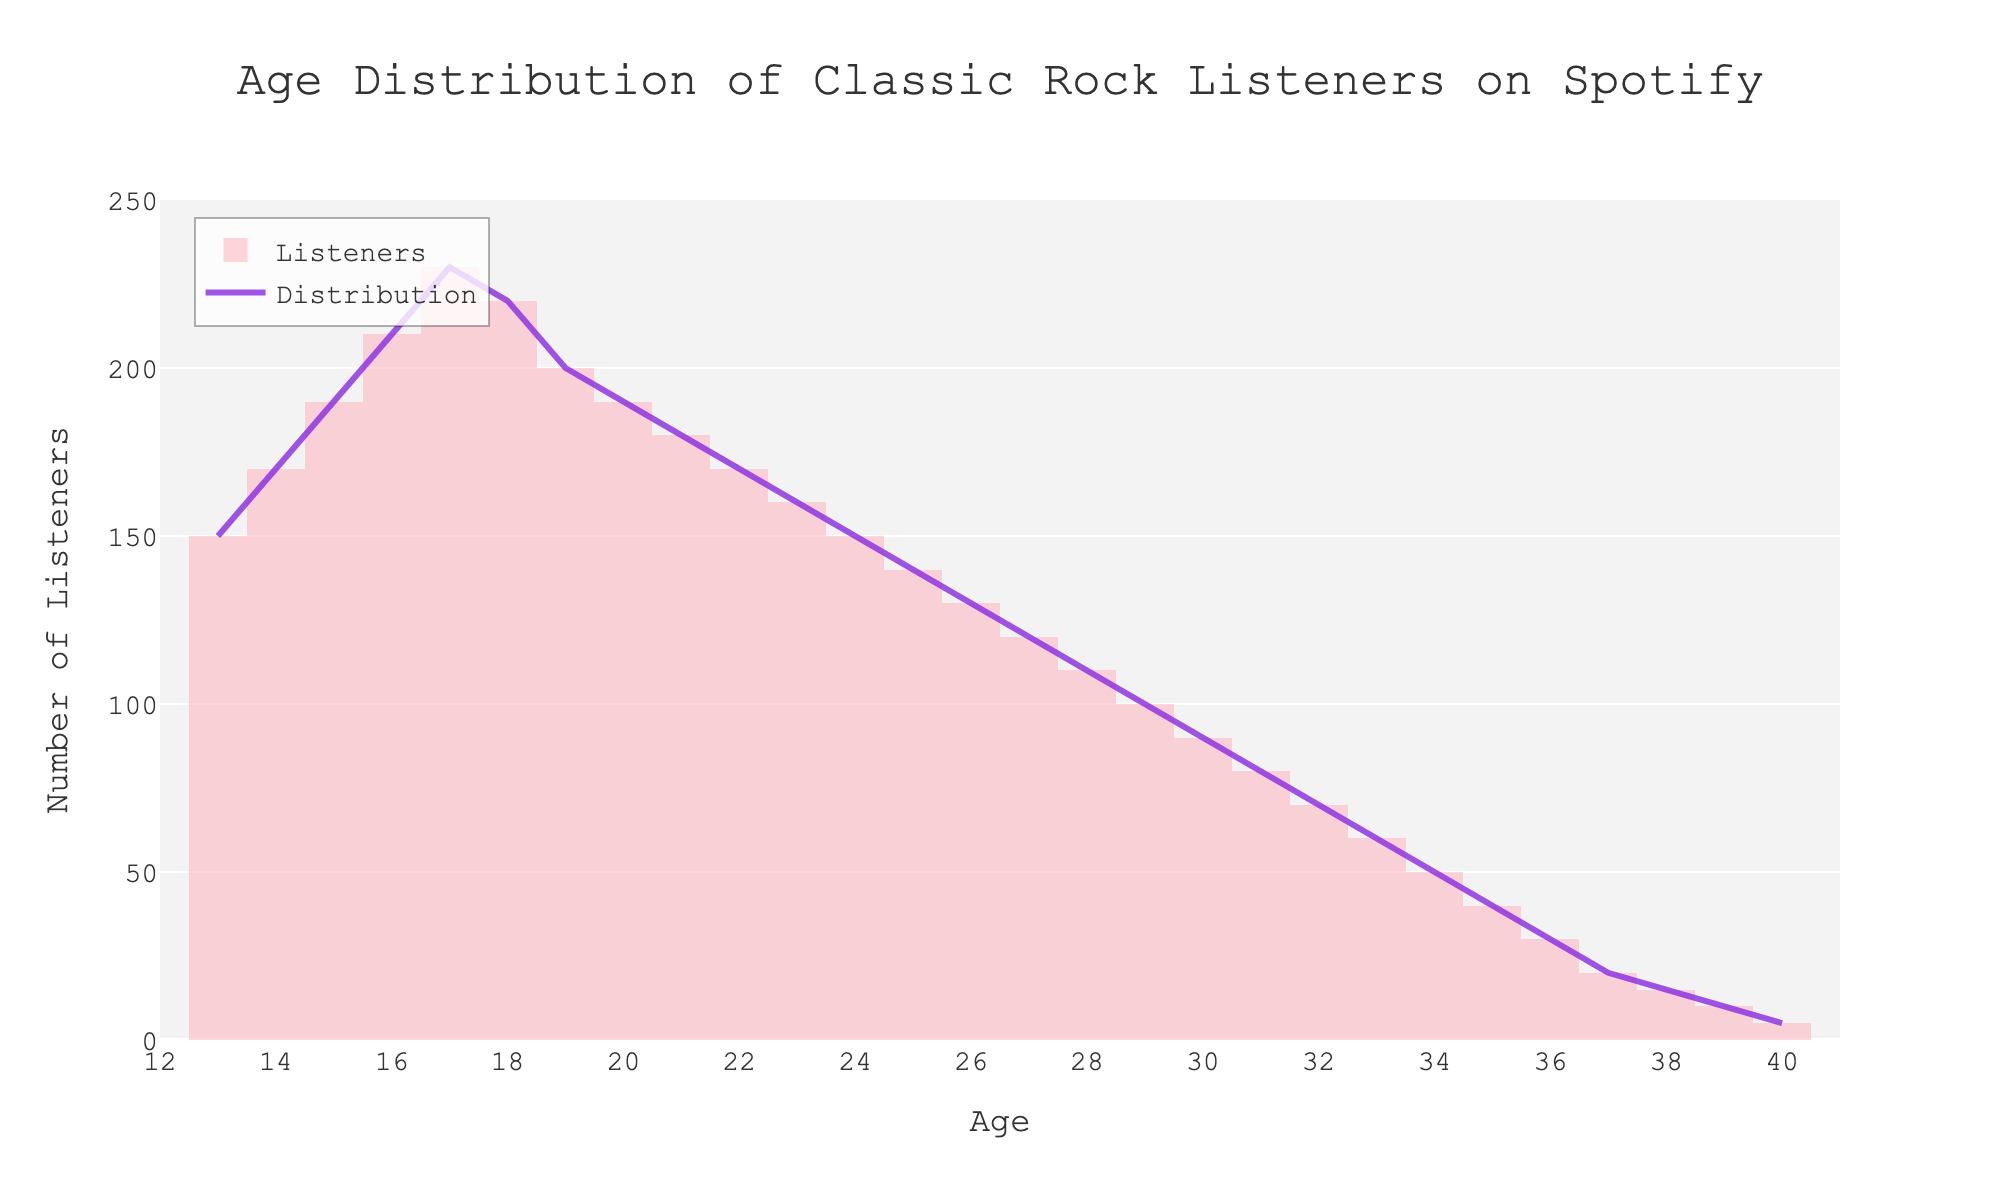What's the title of the figure? The title of a figure is usually displayed at the top and summarizes the information presented. Here, it is stated clearly at the top.
Answer: Age Distribution of Classic Rock Listeners on Spotify What age group has the highest number of listeners? To find the age group with the highest listeners, look for the peak in the histogram or the line plot. The highest peak occurs at age 17.
Answer: 17 Which age group has the lowest number of listeners? Look at the lowest point in the histogram where the number of listeners is shown to be the least. The lowest point occurs at age 40.
Answer: 40 Between the ages of 20 and 30, which age has the most listeners? Focus on the histogram or line plot between ages 20 and 30 and identify the age with the highest number of listeners. Age 20 has a higher number compared to others in that range.
Answer: 20 What can you say about the trend of listeners as age increases from 13 to 40? Observe the general direction of the plots: the number of listeners increases until age 17 and then gradually decreases as age increases.
Answer: Increases till 17, then decreases How many different age groups are represented in this plot? The x-axis displays ranging from the youngest to the oldest listener's age, including all unique ages. Counting from age 13 to 40, there are 28 age groups.
Answer: 28 What is the sum of listeners aged 24 and 25? Identify the number of listeners at ages 24 (150) and 25 (140) and add them together.
Answer: 290 How does the number of listeners aged 15 compare to that of listeners aged 30? Check the histogram values for ages 15 and 30. The listeners at age 15 are 190 while those at age 30 are 90. Compare the values.
Answer: 15 has 100 more What's the average number of listeners for ages 13 to 15? Sum the listeners for ages 13 (150), 14 (170), and 15 (190), which equals 510, then divide by 3.
Answer: 170 How does the listener distribution change visually as age progresses? Starting from age 13, observe the histogram and line plot trends for changes in listener distribution, noting peaks, valleys, and slopes. Initially increasing till age 17, then a steady decline.
Answer: Peaks at 17, then declines 